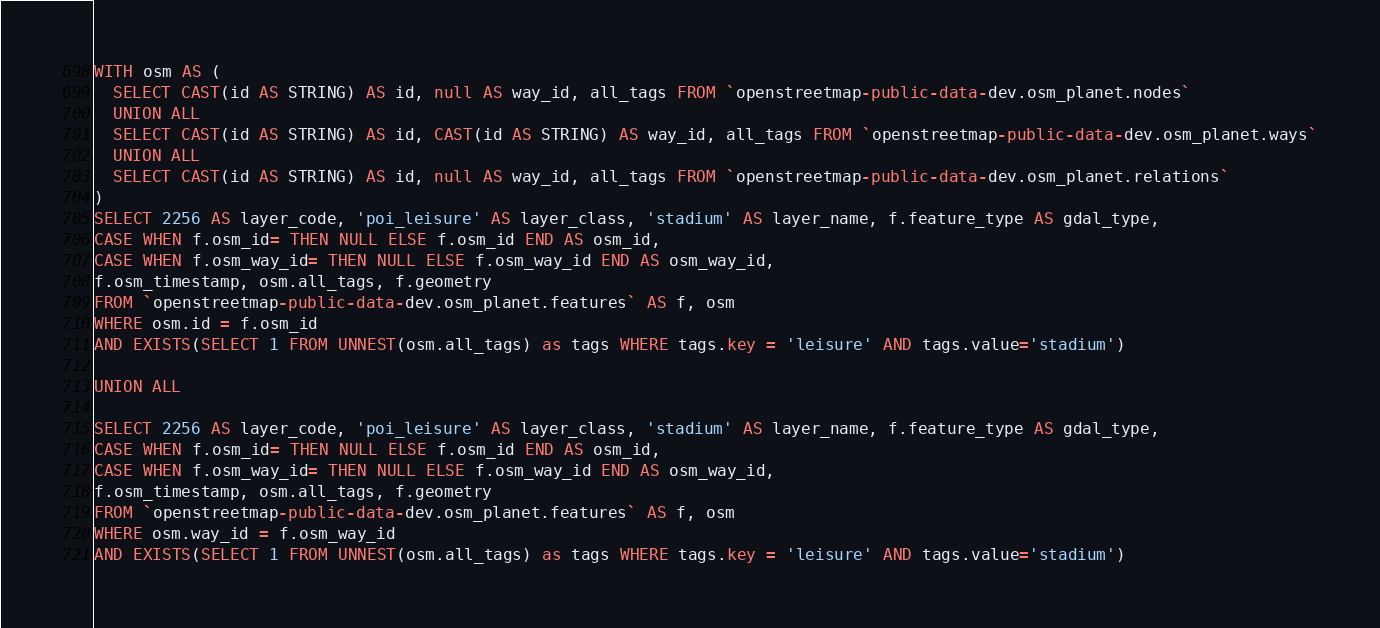Convert code to text. <code><loc_0><loc_0><loc_500><loc_500><_SQL_>
WITH osm AS (
  SELECT CAST(id AS STRING) AS id, null AS way_id, all_tags FROM `openstreetmap-public-data-dev.osm_planet.nodes`
  UNION ALL
  SELECT CAST(id AS STRING) AS id, CAST(id AS STRING) AS way_id, all_tags FROM `openstreetmap-public-data-dev.osm_planet.ways`
  UNION ALL
  SELECT CAST(id AS STRING) AS id, null AS way_id, all_tags FROM `openstreetmap-public-data-dev.osm_planet.relations`
)
SELECT 2256 AS layer_code, 'poi_leisure' AS layer_class, 'stadium' AS layer_name, f.feature_type AS gdal_type,
CASE WHEN f.osm_id= THEN NULL ELSE f.osm_id END AS osm_id,
CASE WHEN f.osm_way_id= THEN NULL ELSE f.osm_way_id END AS osm_way_id,
f.osm_timestamp, osm.all_tags, f.geometry
FROM `openstreetmap-public-data-dev.osm_planet.features` AS f, osm
WHERE osm.id = f.osm_id
AND EXISTS(SELECT 1 FROM UNNEST(osm.all_tags) as tags WHERE tags.key = 'leisure' AND tags.value='stadium')

UNION ALL

SELECT 2256 AS layer_code, 'poi_leisure' AS layer_class, 'stadium' AS layer_name, f.feature_type AS gdal_type,
CASE WHEN f.osm_id= THEN NULL ELSE f.osm_id END AS osm_id,
CASE WHEN f.osm_way_id= THEN NULL ELSE f.osm_way_id END AS osm_way_id,
f.osm_timestamp, osm.all_tags, f.geometry
FROM `openstreetmap-public-data-dev.osm_planet.features` AS f, osm
WHERE osm.way_id = f.osm_way_id
AND EXISTS(SELECT 1 FROM UNNEST(osm.all_tags) as tags WHERE tags.key = 'leisure' AND tags.value='stadium')

</code> 